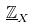Convert formula to latex. <formula><loc_0><loc_0><loc_500><loc_500>\underline { \mathbb { Z } } _ { X }</formula> 